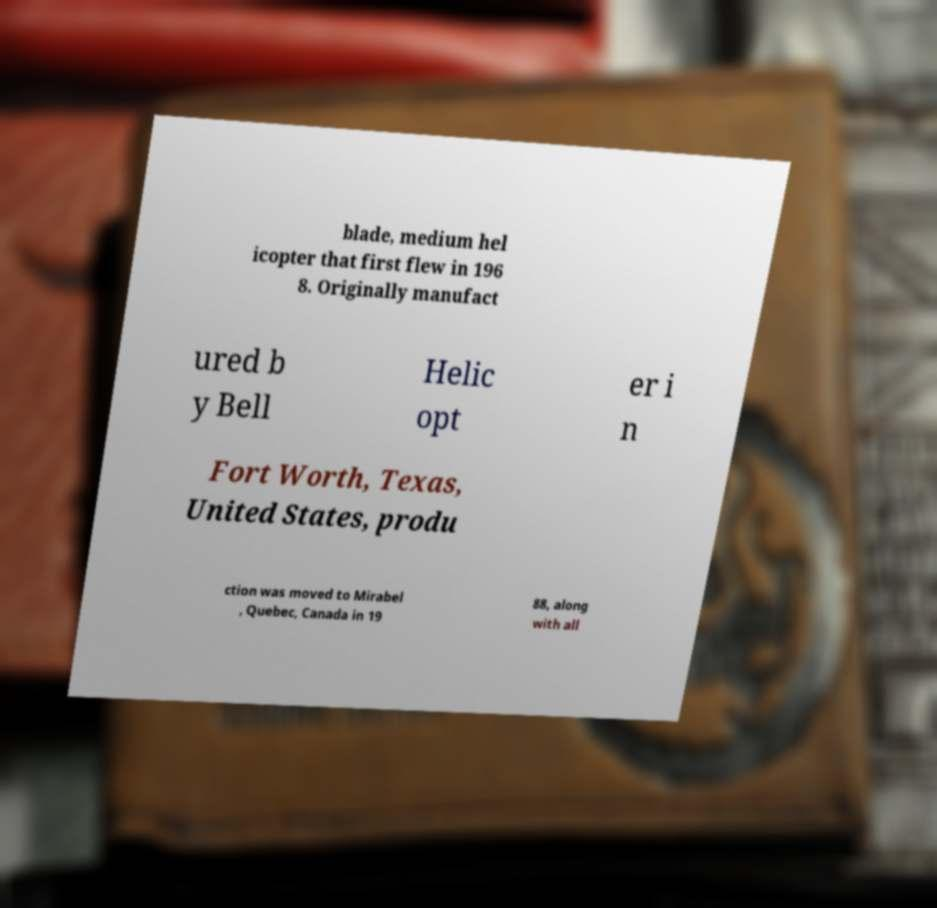Can you read and provide the text displayed in the image?This photo seems to have some interesting text. Can you extract and type it out for me? blade, medium hel icopter that first flew in 196 8. Originally manufact ured b y Bell Helic opt er i n Fort Worth, Texas, United States, produ ction was moved to Mirabel , Quebec, Canada in 19 88, along with all 